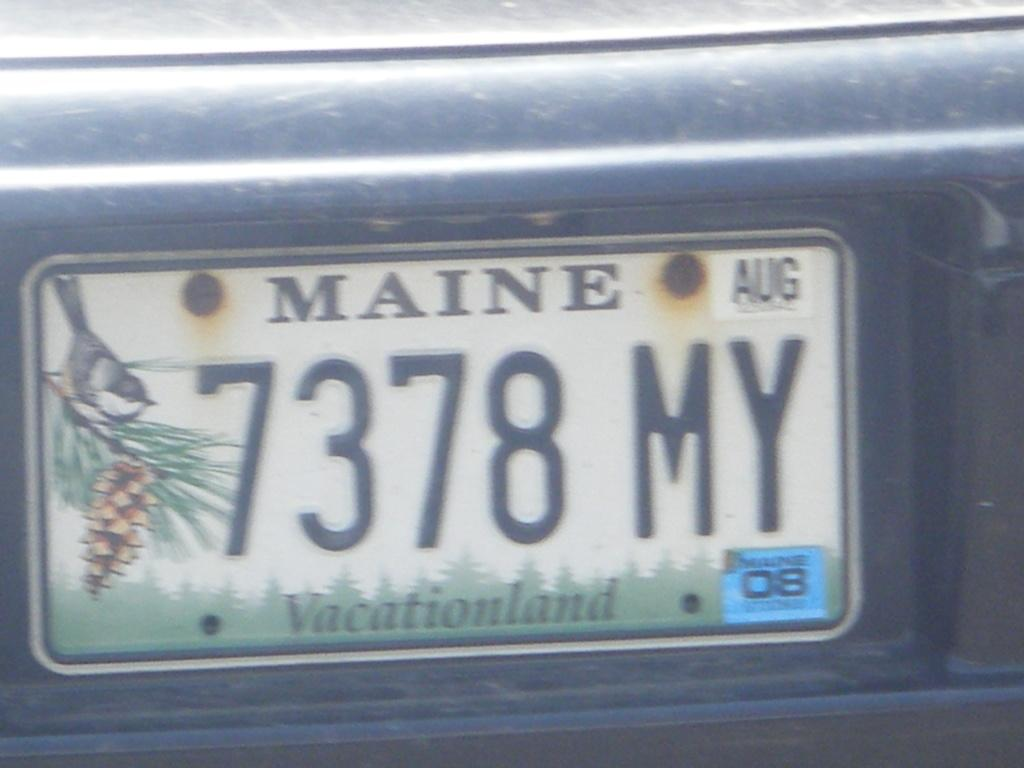<image>
Write a terse but informative summary of the picture. License plate from Maine which says 7378MY on it. 